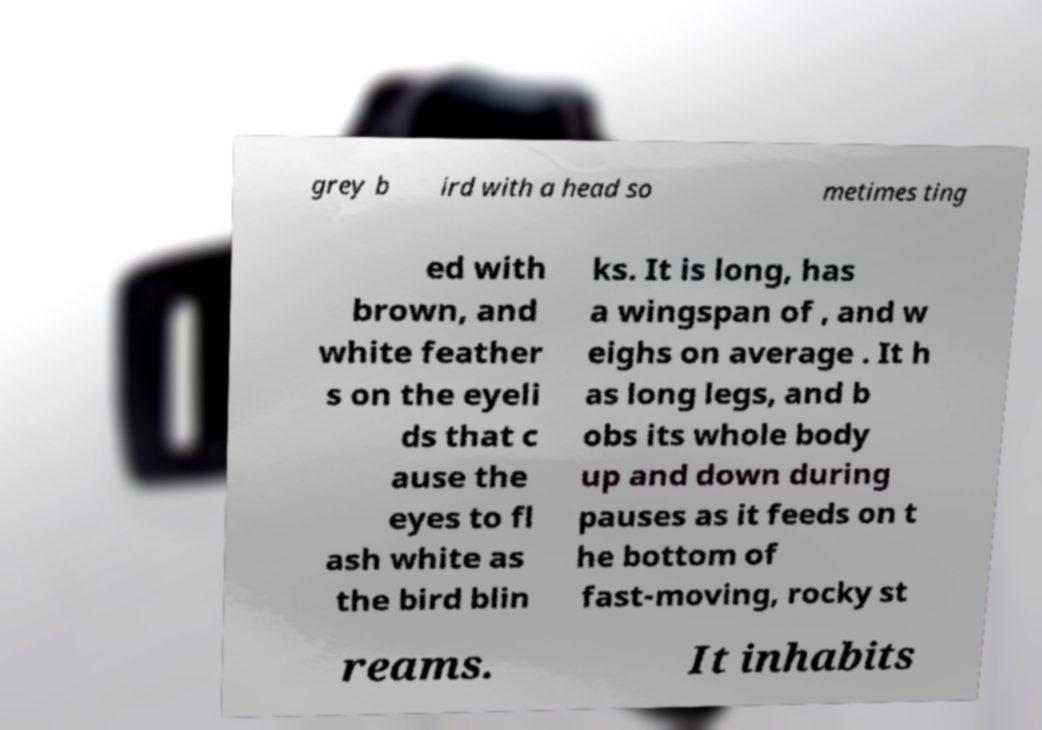Can you accurately transcribe the text from the provided image for me? grey b ird with a head so metimes ting ed with brown, and white feather s on the eyeli ds that c ause the eyes to fl ash white as the bird blin ks. It is long, has a wingspan of , and w eighs on average . It h as long legs, and b obs its whole body up and down during pauses as it feeds on t he bottom of fast-moving, rocky st reams. It inhabits 